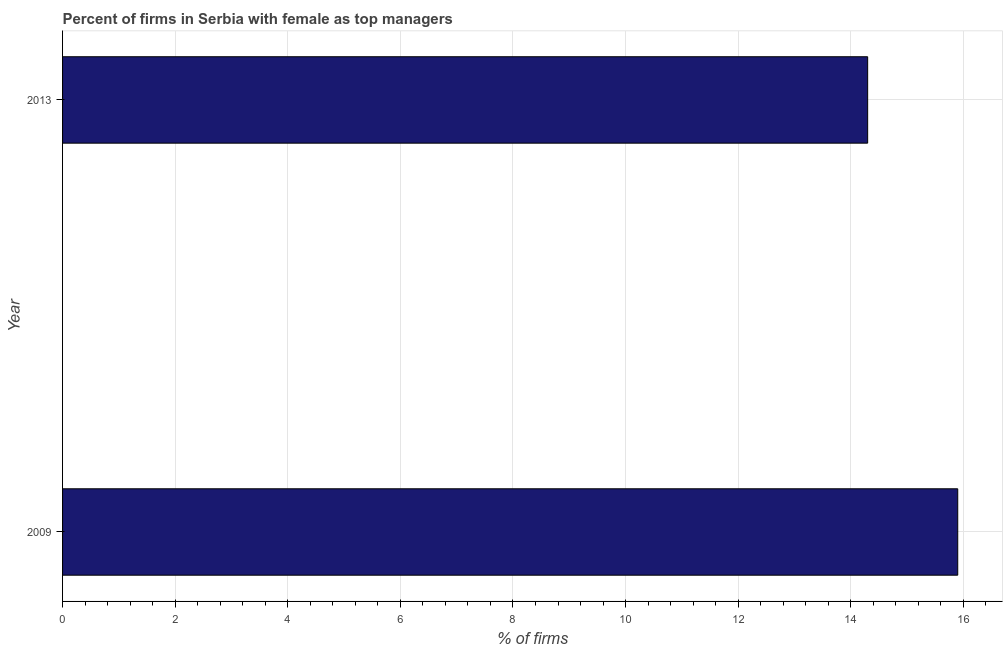Does the graph contain grids?
Ensure brevity in your answer.  Yes. What is the title of the graph?
Your answer should be very brief. Percent of firms in Serbia with female as top managers. What is the label or title of the X-axis?
Offer a very short reply. % of firms. Across all years, what is the minimum percentage of firms with female as top manager?
Ensure brevity in your answer.  14.3. In which year was the percentage of firms with female as top manager maximum?
Offer a very short reply. 2009. What is the sum of the percentage of firms with female as top manager?
Offer a terse response. 30.2. What is the difference between the percentage of firms with female as top manager in 2009 and 2013?
Ensure brevity in your answer.  1.6. What is the average percentage of firms with female as top manager per year?
Ensure brevity in your answer.  15.1. What is the median percentage of firms with female as top manager?
Make the answer very short. 15.1. In how many years, is the percentage of firms with female as top manager greater than 13.2 %?
Offer a very short reply. 2. Do a majority of the years between 2009 and 2013 (inclusive) have percentage of firms with female as top manager greater than 8.4 %?
Give a very brief answer. Yes. What is the ratio of the percentage of firms with female as top manager in 2009 to that in 2013?
Keep it short and to the point. 1.11. Is the percentage of firms with female as top manager in 2009 less than that in 2013?
Give a very brief answer. No. How many bars are there?
Ensure brevity in your answer.  2. How many years are there in the graph?
Keep it short and to the point. 2. What is the difference between two consecutive major ticks on the X-axis?
Your answer should be compact. 2. Are the values on the major ticks of X-axis written in scientific E-notation?
Your answer should be compact. No. What is the % of firms in 2013?
Keep it short and to the point. 14.3. What is the ratio of the % of firms in 2009 to that in 2013?
Provide a short and direct response. 1.11. 